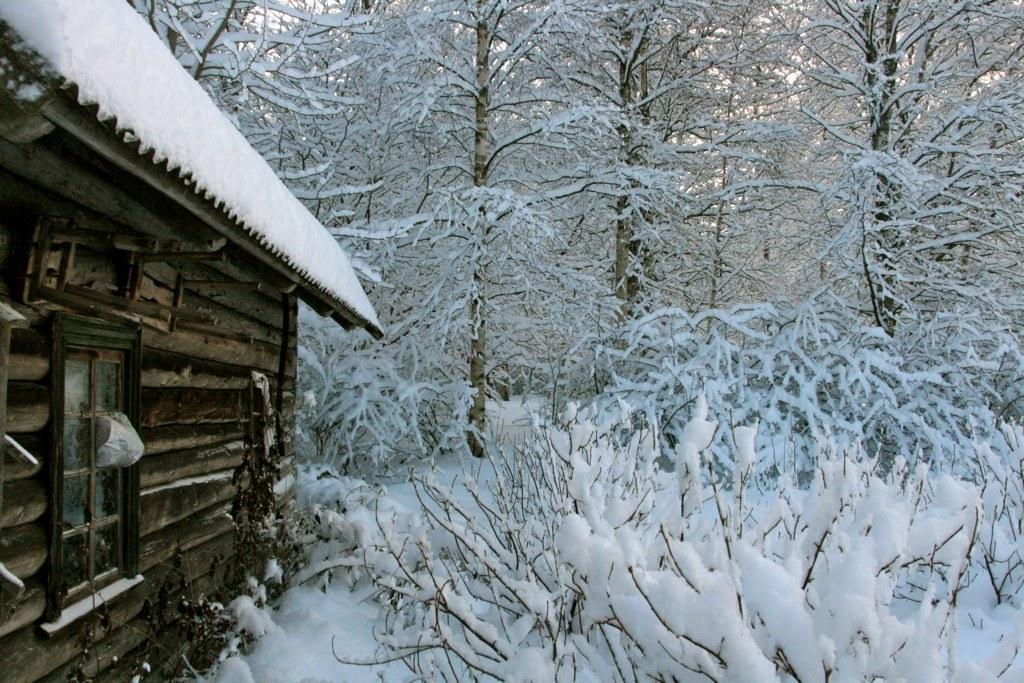Describe this image in one or two sentences. In the image on the left side we can see one hit,window and roof. In the background we can see trees and snow. 